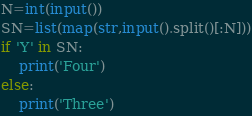<code> <loc_0><loc_0><loc_500><loc_500><_Python_>N=int(input())
SN=list(map(str,input().split()[:N]))
if 'Y' in SN:
    print('Four')
else:
    print('Three')</code> 